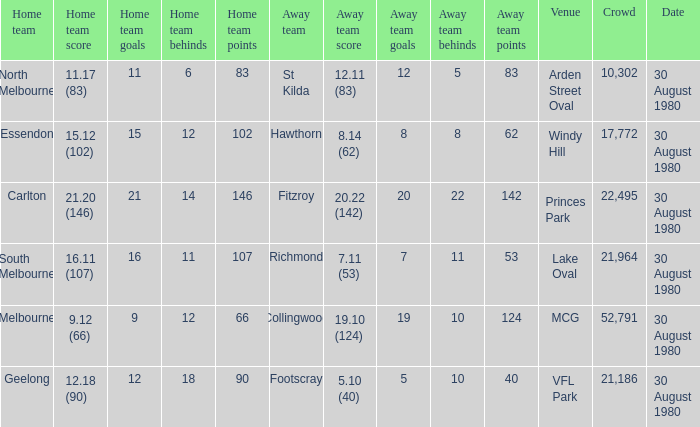Help me parse the entirety of this table. {'header': ['Home team', 'Home team score', 'Home team goals', 'Home team behinds', 'Home team points', 'Away team', 'Away team score', 'Away team goals', 'Away team behinds', 'Away team points', 'Venue', 'Crowd', 'Date'], 'rows': [['North Melbourne', '11.17 (83)', '11', '6', '83', 'St Kilda', '12.11 (83)', '12', '5', '83', 'Arden Street Oval', '10,302', '30 August 1980'], ['Essendon', '15.12 (102)', '15', '12', '102', 'Hawthorn', '8.14 (62)', '8', '8', '62', 'Windy Hill', '17,772', '30 August 1980'], ['Carlton', '21.20 (146)', '21', '14', '146', 'Fitzroy', '20.22 (142)', '20', '22', '142', 'Princes Park', '22,495', '30 August 1980'], ['South Melbourne', '16.11 (107)', '16', '11', '107', 'Richmond', '7.11 (53)', '7', '11', '53', 'Lake Oval', '21,964', '30 August 1980'], ['Melbourne', '9.12 (66)', '9', '12', '66', 'Collingwood', '19.10 (124)', '19', '10', '124', 'MCG', '52,791', '30 August 1980'], ['Geelong', '12.18 (90)', '12', '18', '90', 'Footscray', '5.10 (40)', '5', '10', '40', 'VFL Park', '21,186', '30 August 1980']]} What was the score for south melbourne at home? 16.11 (107). 